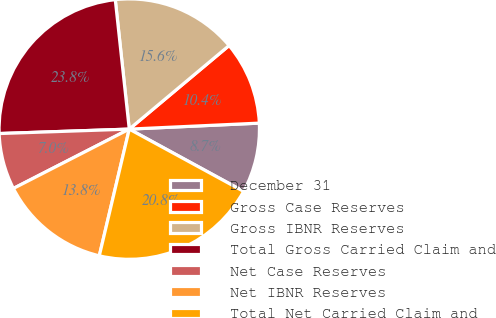Convert chart to OTSL. <chart><loc_0><loc_0><loc_500><loc_500><pie_chart><fcel>December 31<fcel>Gross Case Reserves<fcel>Gross IBNR Reserves<fcel>Total Gross Carried Claim and<fcel>Net Case Reserves<fcel>Net IBNR Reserves<fcel>Total Net Carried Claim and<nl><fcel>8.67%<fcel>10.36%<fcel>15.62%<fcel>23.83%<fcel>6.99%<fcel>13.77%<fcel>20.76%<nl></chart> 